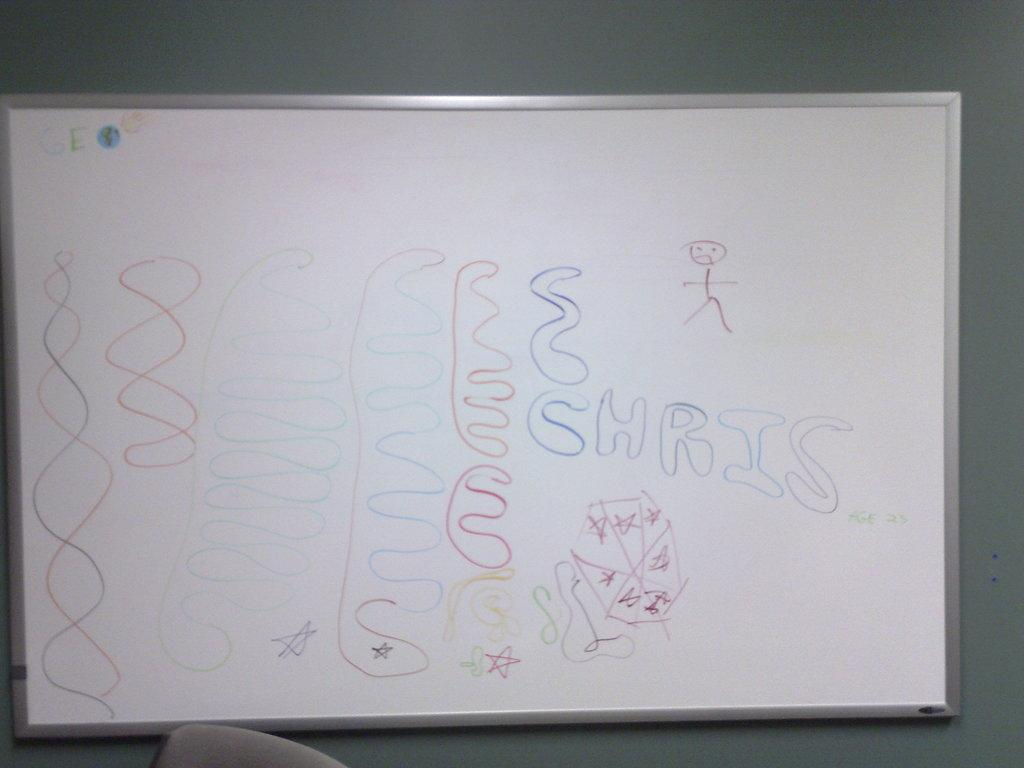<image>
Summarize the visual content of the image. someone dooodled on the white board an wrote the name chris 